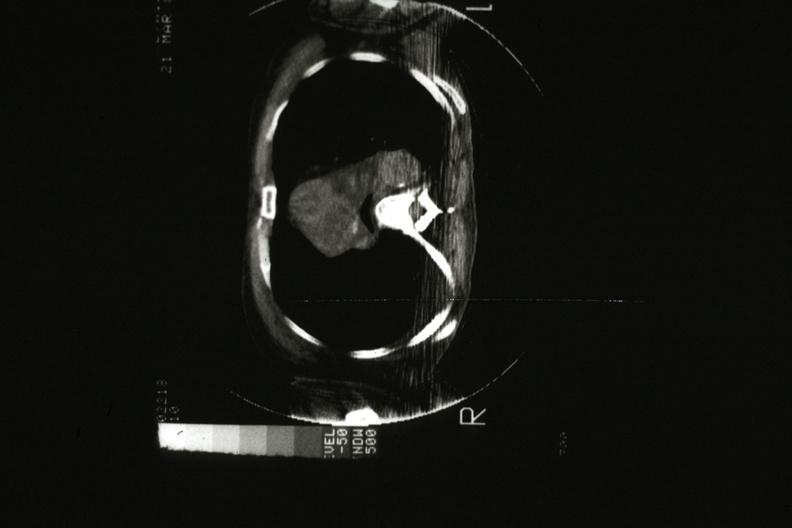what is present?
Answer the question using a single word or phrase. Thymus 